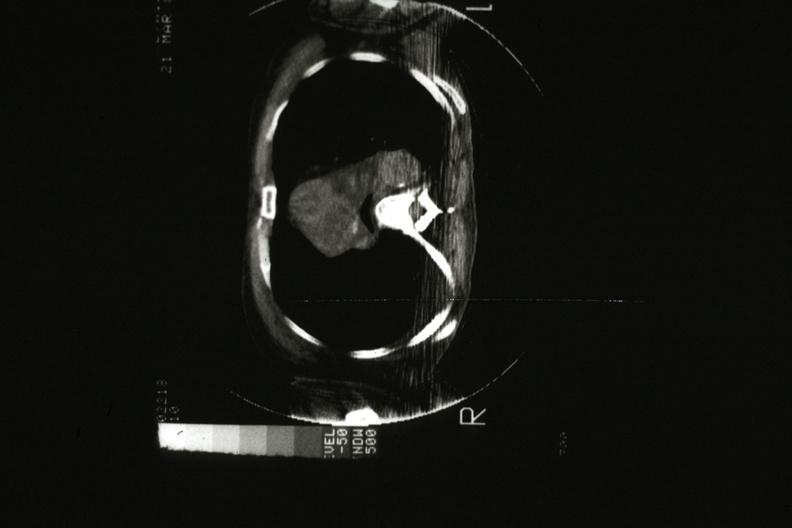what is present?
Answer the question using a single word or phrase. Thymus 